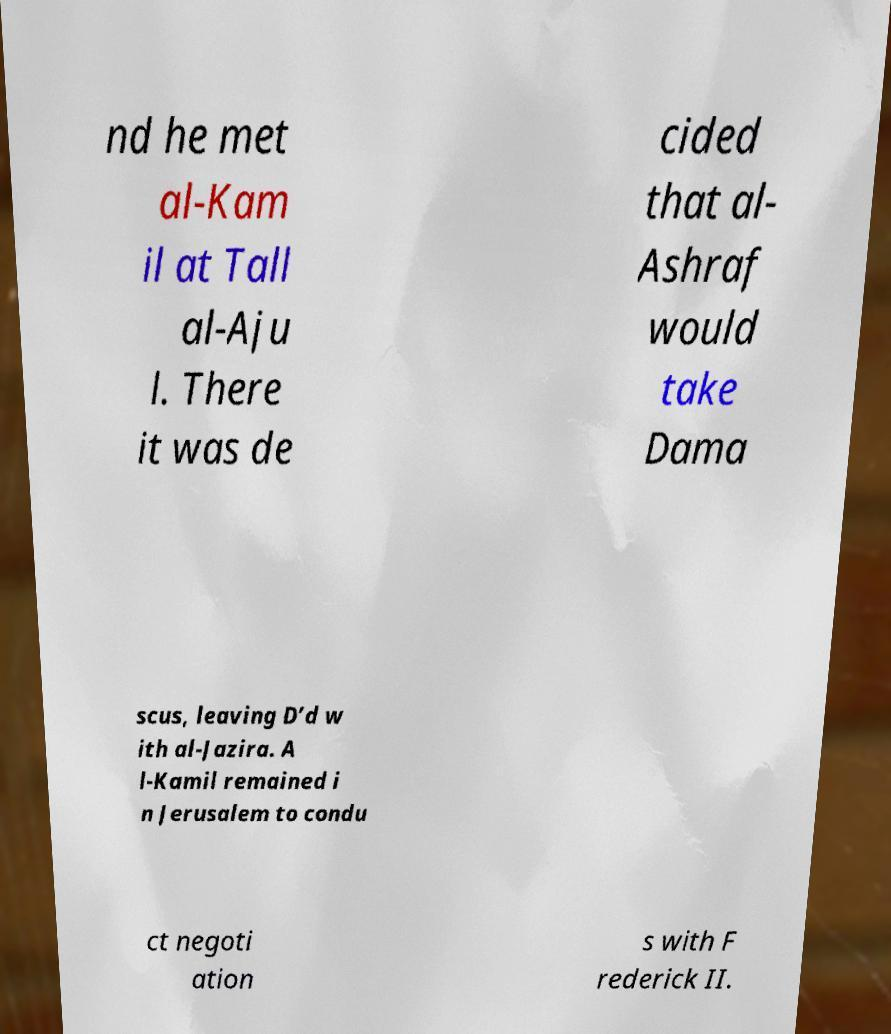For documentation purposes, I need the text within this image transcribed. Could you provide that? nd he met al-Kam il at Tall al-Aju l. There it was de cided that al- Ashraf would take Dama scus, leaving D’d w ith al-Jazira. A l-Kamil remained i n Jerusalem to condu ct negoti ation s with F rederick II. 